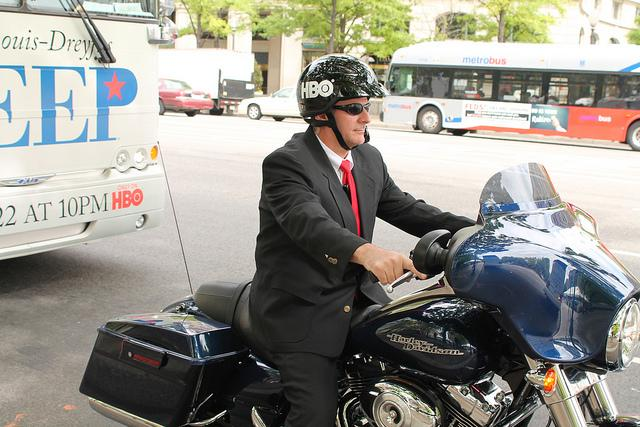The man on the motorcycle is pretending to act as what type of person? Please explain your reasoning. secret serviceman. The man is in a black suit and wearing sunglasses. 